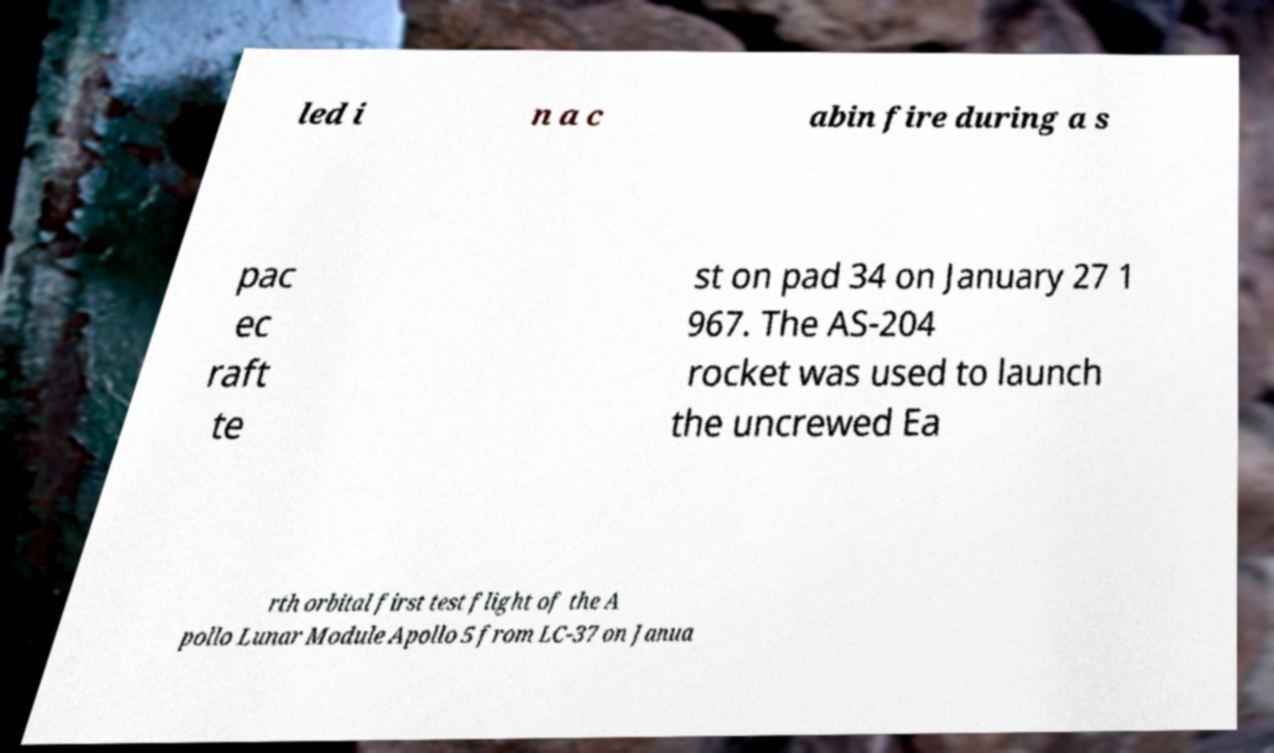I need the written content from this picture converted into text. Can you do that? led i n a c abin fire during a s pac ec raft te st on pad 34 on January 27 1 967. The AS-204 rocket was used to launch the uncrewed Ea rth orbital first test flight of the A pollo Lunar Module Apollo 5 from LC-37 on Janua 